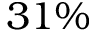Convert formula to latex. <formula><loc_0><loc_0><loc_500><loc_500>3 1 \%</formula> 